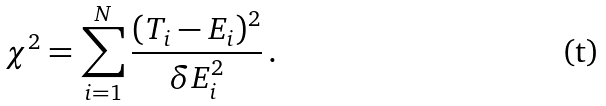<formula> <loc_0><loc_0><loc_500><loc_500>\chi ^ { 2 } = \sum _ { i = 1 } ^ { N } \frac { ( T _ { i } - E _ { i } ) ^ { 2 } } { \delta E _ { i } ^ { 2 } } \, .</formula> 